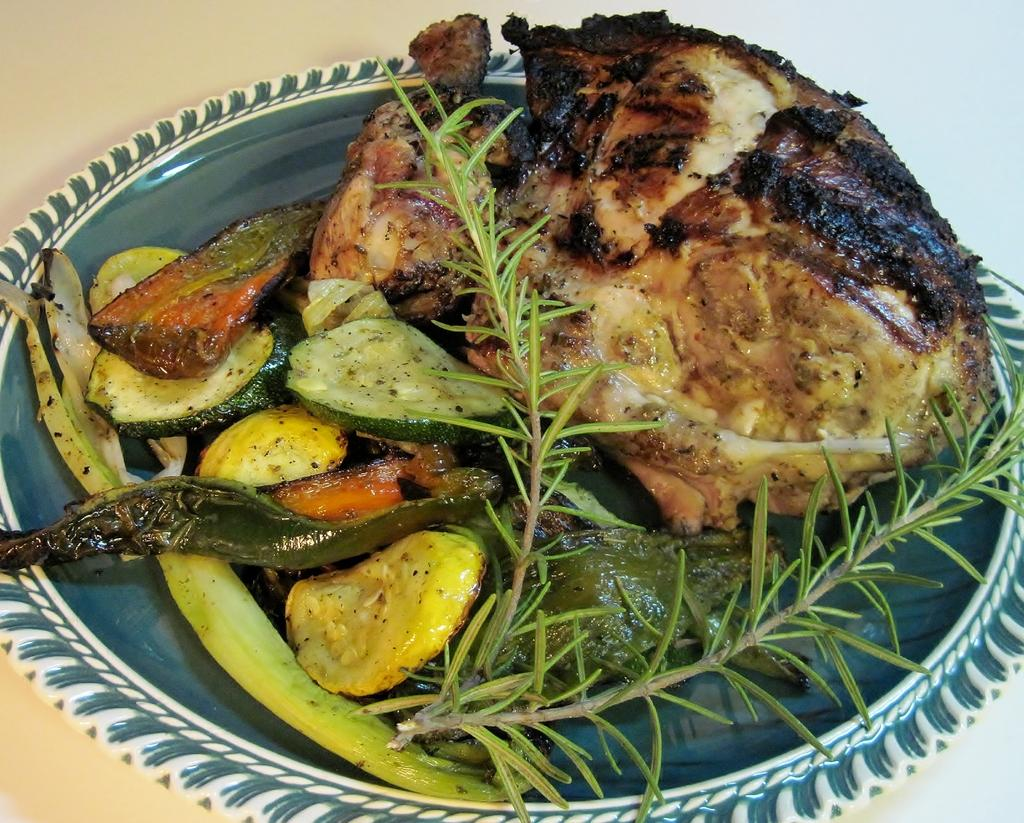What is on the plate that is visible in the image? The plate contains fried vegetables, leaves, and meat. Where is the plate located in the image? The plate is placed on a table. What type of room is the image taken in? The image is taken in a room. How many frogs are sitting on the plate in the image? There are no frogs present on the plate in the image. What type of ants can be seen crawling on the table in the image? There are no ants visible in the image; it only shows a plate with food on a table in a room. 